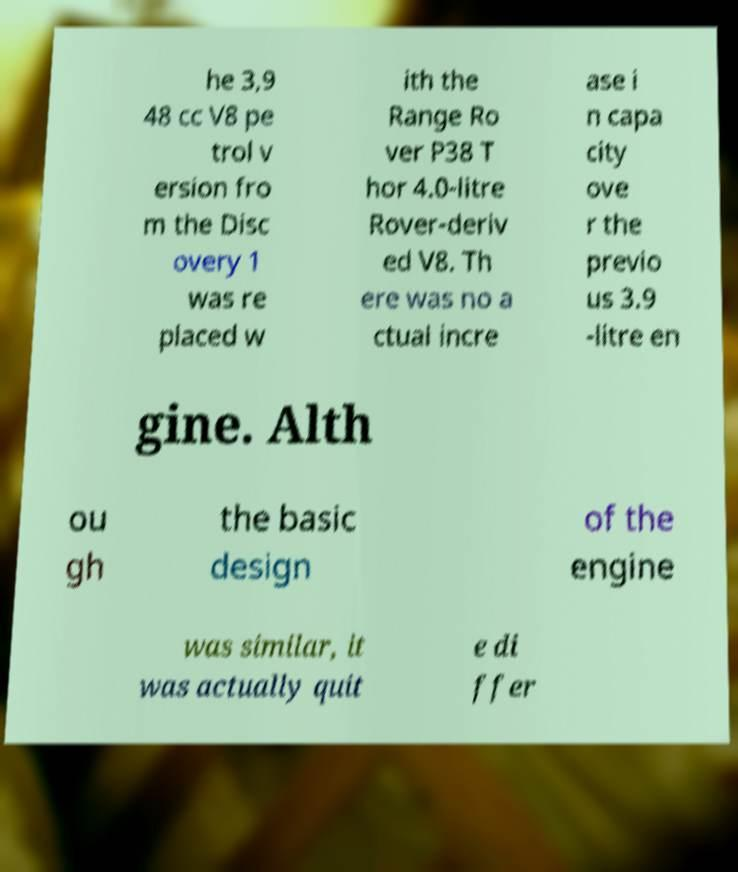Could you assist in decoding the text presented in this image and type it out clearly? he 3,9 48 cc V8 pe trol v ersion fro m the Disc overy 1 was re placed w ith the Range Ro ver P38 T hor 4.0-litre Rover-deriv ed V8. Th ere was no a ctual incre ase i n capa city ove r the previo us 3.9 -litre en gine. Alth ou gh the basic design of the engine was similar, it was actually quit e di ffer 